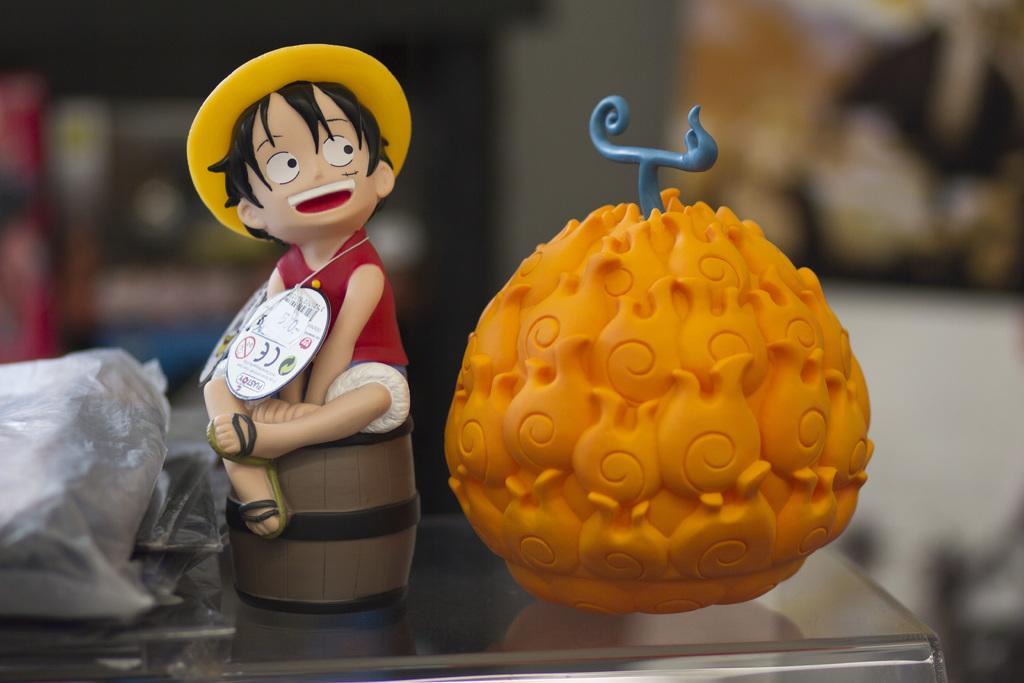How would you summarize this image in a sentence or two? On this glass surface we can see toys and plastic cover. Background of the image it is blur. 